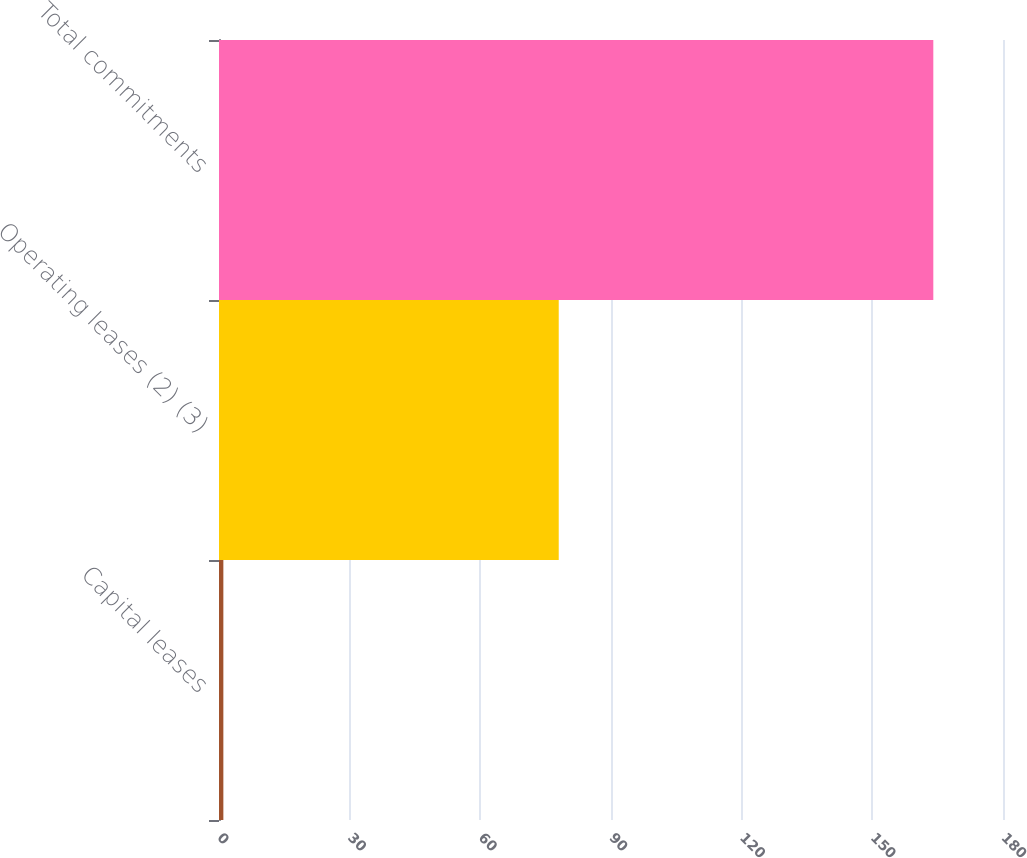<chart> <loc_0><loc_0><loc_500><loc_500><bar_chart><fcel>Capital leases<fcel>Operating leases (2) (3)<fcel>Total commitments<nl><fcel>1<fcel>78<fcel>164<nl></chart> 